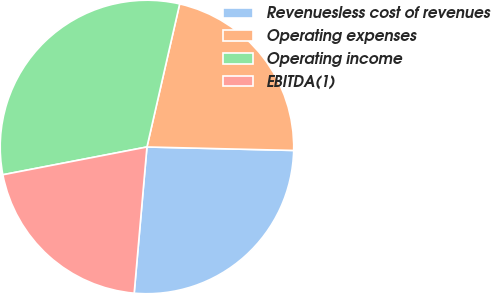<chart> <loc_0><loc_0><loc_500><loc_500><pie_chart><fcel>Revenuesless cost of revenues<fcel>Operating expenses<fcel>Operating income<fcel>EBITDA(1)<nl><fcel>26.01%<fcel>21.8%<fcel>31.61%<fcel>20.58%<nl></chart> 